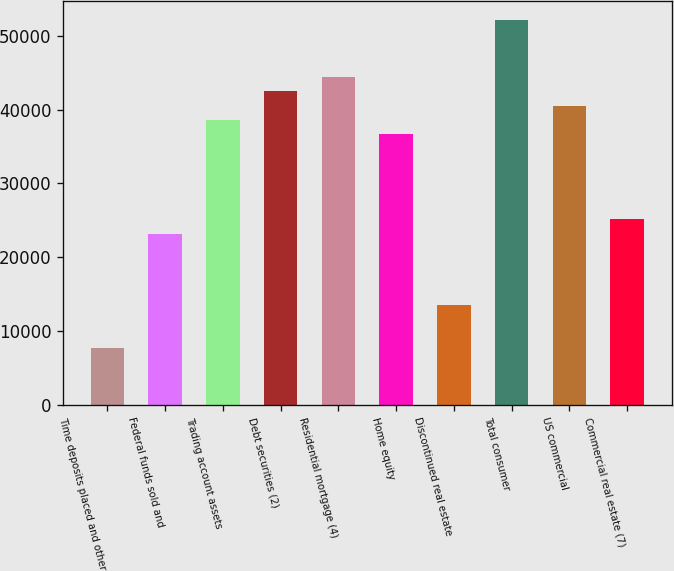Convert chart to OTSL. <chart><loc_0><loc_0><loc_500><loc_500><bar_chart><fcel>Time deposits placed and other<fcel>Federal funds sold and<fcel>Trading account assets<fcel>Debt securities (2)<fcel>Residential mortgage (4)<fcel>Home equity<fcel>Discontinued real estate<fcel>Total consumer<fcel>US commercial<fcel>Commercial real estate (7)<nl><fcel>7725.8<fcel>23171.4<fcel>38617<fcel>42478.4<fcel>44409.1<fcel>36686.3<fcel>13517.9<fcel>52131.9<fcel>40547.7<fcel>25102.1<nl></chart> 